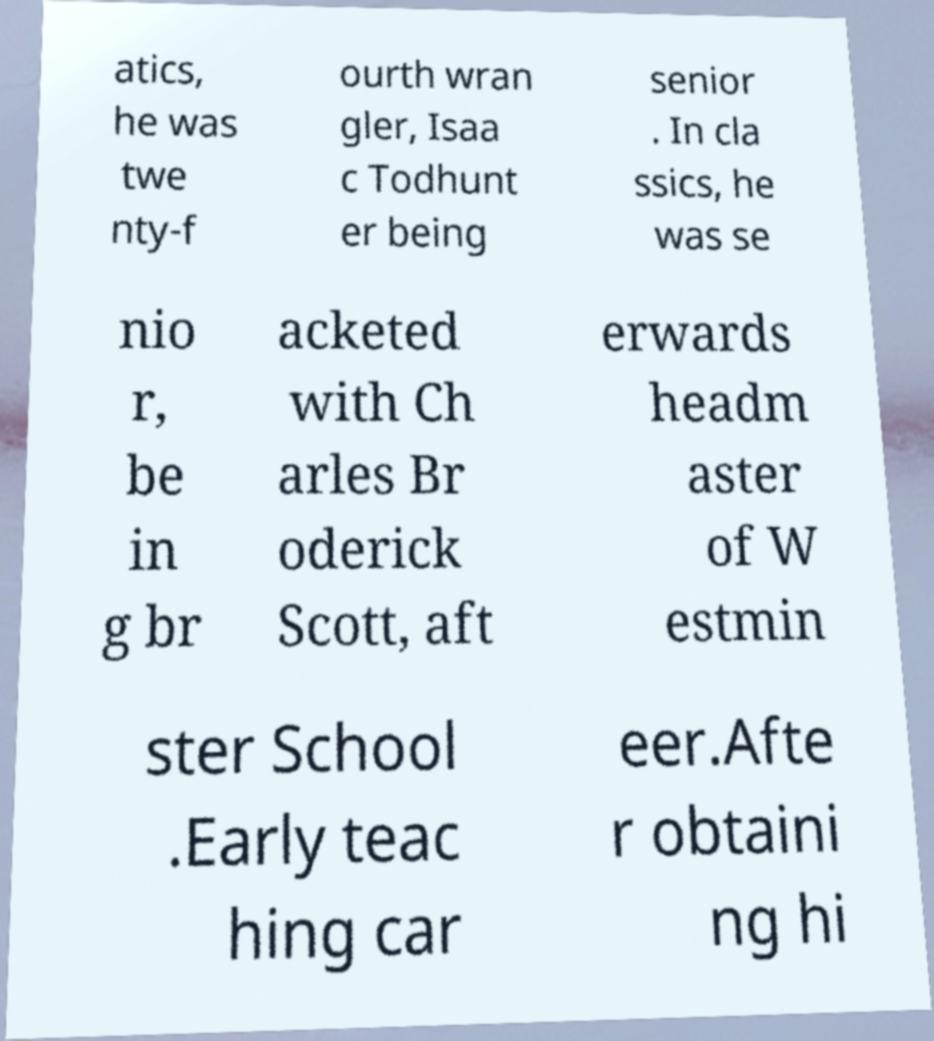Can you read and provide the text displayed in the image?This photo seems to have some interesting text. Can you extract and type it out for me? atics, he was twe nty-f ourth wran gler, Isaa c Todhunt er being senior . In cla ssics, he was se nio r, be in g br acketed with Ch arles Br oderick Scott, aft erwards headm aster of W estmin ster School .Early teac hing car eer.Afte r obtaini ng hi 